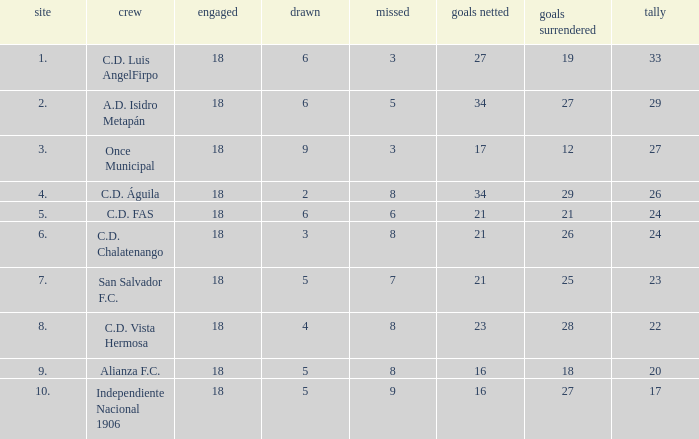What are the number of goals conceded that has a played greater than 18? 0.0. Parse the full table. {'header': ['site', 'crew', 'engaged', 'drawn', 'missed', 'goals netted', 'goals surrendered', 'tally'], 'rows': [['1.', 'C.D. Luis AngelFirpo', '18', '6', '3', '27', '19', '33'], ['2.', 'A.D. Isidro Metapán', '18', '6', '5', '34', '27', '29'], ['3.', 'Once Municipal', '18', '9', '3', '17', '12', '27'], ['4.', 'C.D. Águila', '18', '2', '8', '34', '29', '26'], ['5.', 'C.D. FAS', '18', '6', '6', '21', '21', '24'], ['6.', 'C.D. Chalatenango', '18', '3', '8', '21', '26', '24'], ['7.', 'San Salvador F.C.', '18', '5', '7', '21', '25', '23'], ['8.', 'C.D. Vista Hermosa', '18', '4', '8', '23', '28', '22'], ['9.', 'Alianza F.C.', '18', '5', '8', '16', '18', '20'], ['10.', 'Independiente Nacional 1906', '18', '5', '9', '16', '27', '17']]} 